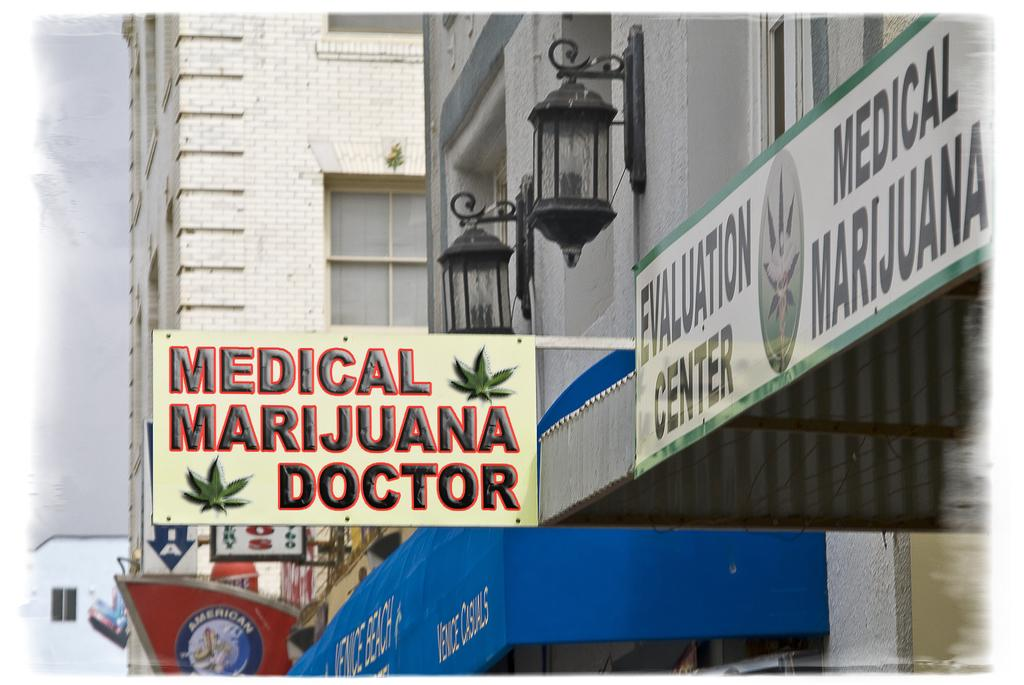What type of structures can be seen in the image? There are buildings in the image. How can the buildings be identified in the image? The buildings have name boards in the image. What else is visible in the image besides the buildings? There are lights in the image. What can be seen in the background of the image? The sky is visible in the background of the image. What type of fruit is being carried by the porter in the image? There is no porter or fruit present in the image. What kind of cart is being used to transport the fruit in the image? There is no cart or fruit present in the image. 